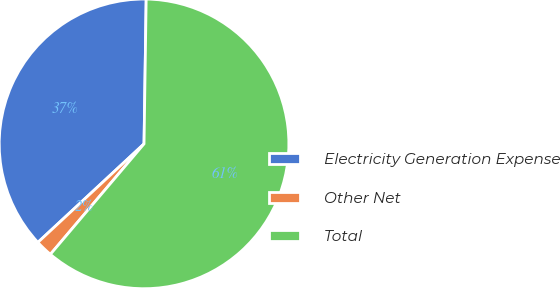<chart> <loc_0><loc_0><loc_500><loc_500><pie_chart><fcel>Electricity Generation Expense<fcel>Other Net<fcel>Total<nl><fcel>37.14%<fcel>1.9%<fcel>60.95%<nl></chart> 